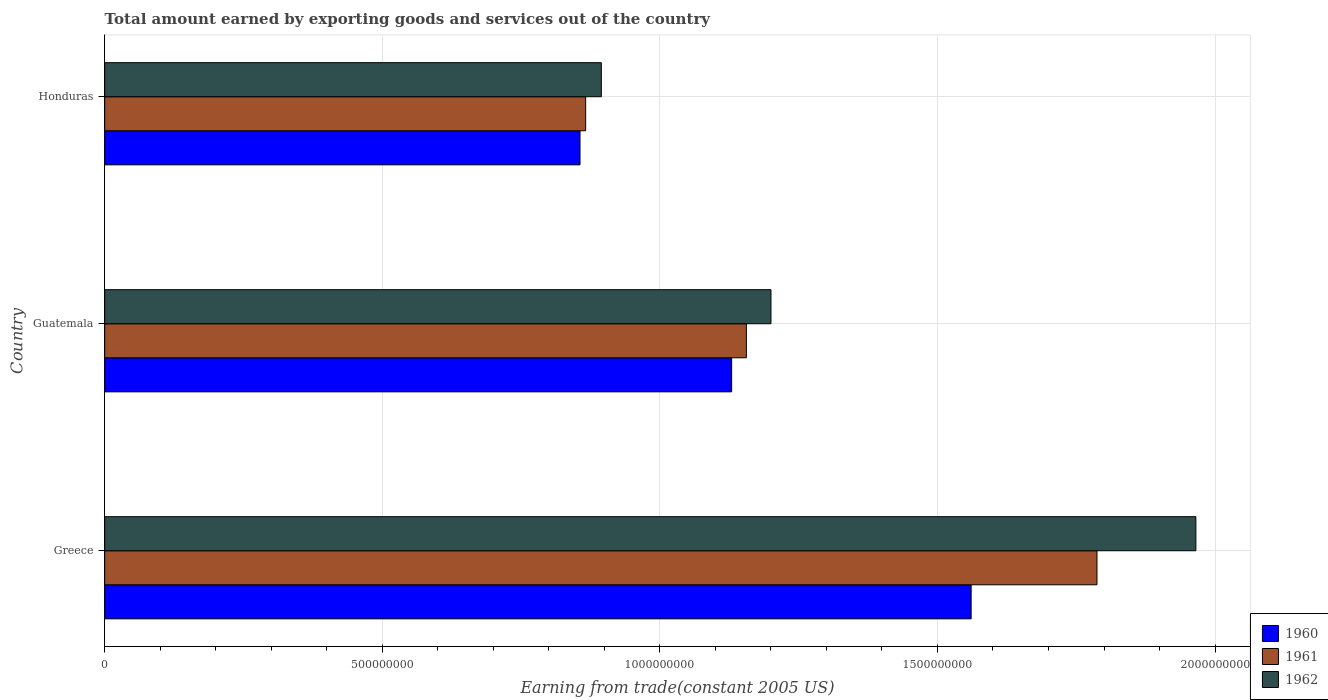How many different coloured bars are there?
Your answer should be very brief. 3. Are the number of bars on each tick of the Y-axis equal?
Your answer should be very brief. Yes. How many bars are there on the 1st tick from the top?
Make the answer very short. 3. How many bars are there on the 2nd tick from the bottom?
Ensure brevity in your answer.  3. What is the label of the 2nd group of bars from the top?
Give a very brief answer. Guatemala. What is the total amount earned by exporting goods and services in 1961 in Greece?
Provide a short and direct response. 1.79e+09. Across all countries, what is the maximum total amount earned by exporting goods and services in 1962?
Give a very brief answer. 1.97e+09. Across all countries, what is the minimum total amount earned by exporting goods and services in 1961?
Your response must be concise. 8.66e+08. In which country was the total amount earned by exporting goods and services in 1962 maximum?
Keep it short and to the point. Greece. In which country was the total amount earned by exporting goods and services in 1960 minimum?
Provide a short and direct response. Honduras. What is the total total amount earned by exporting goods and services in 1961 in the graph?
Offer a very short reply. 3.81e+09. What is the difference between the total amount earned by exporting goods and services in 1961 in Greece and that in Guatemala?
Give a very brief answer. 6.32e+08. What is the difference between the total amount earned by exporting goods and services in 1961 in Guatemala and the total amount earned by exporting goods and services in 1962 in Honduras?
Offer a very short reply. 2.61e+08. What is the average total amount earned by exporting goods and services in 1962 per country?
Your answer should be compact. 1.35e+09. What is the difference between the total amount earned by exporting goods and services in 1960 and total amount earned by exporting goods and services in 1961 in Honduras?
Provide a succinct answer. -1.02e+07. In how many countries, is the total amount earned by exporting goods and services in 1960 greater than 800000000 US$?
Offer a terse response. 3. What is the ratio of the total amount earned by exporting goods and services in 1960 in Greece to that in Guatemala?
Provide a short and direct response. 1.38. What is the difference between the highest and the second highest total amount earned by exporting goods and services in 1962?
Your answer should be compact. 7.65e+08. What is the difference between the highest and the lowest total amount earned by exporting goods and services in 1960?
Your response must be concise. 7.05e+08. In how many countries, is the total amount earned by exporting goods and services in 1961 greater than the average total amount earned by exporting goods and services in 1961 taken over all countries?
Make the answer very short. 1. What does the 1st bar from the top in Greece represents?
Provide a short and direct response. 1962. Is it the case that in every country, the sum of the total amount earned by exporting goods and services in 1962 and total amount earned by exporting goods and services in 1961 is greater than the total amount earned by exporting goods and services in 1960?
Give a very brief answer. Yes. How many bars are there?
Offer a very short reply. 9. Are all the bars in the graph horizontal?
Your answer should be compact. Yes. Are the values on the major ticks of X-axis written in scientific E-notation?
Keep it short and to the point. No. Does the graph contain any zero values?
Your response must be concise. No. Where does the legend appear in the graph?
Your response must be concise. Bottom right. How many legend labels are there?
Provide a short and direct response. 3. How are the legend labels stacked?
Provide a short and direct response. Vertical. What is the title of the graph?
Your answer should be compact. Total amount earned by exporting goods and services out of the country. What is the label or title of the X-axis?
Your response must be concise. Earning from trade(constant 2005 US). What is the Earning from trade(constant 2005 US) of 1960 in Greece?
Offer a very short reply. 1.56e+09. What is the Earning from trade(constant 2005 US) of 1961 in Greece?
Ensure brevity in your answer.  1.79e+09. What is the Earning from trade(constant 2005 US) in 1962 in Greece?
Keep it short and to the point. 1.97e+09. What is the Earning from trade(constant 2005 US) of 1960 in Guatemala?
Offer a terse response. 1.13e+09. What is the Earning from trade(constant 2005 US) of 1961 in Guatemala?
Your answer should be compact. 1.16e+09. What is the Earning from trade(constant 2005 US) in 1962 in Guatemala?
Offer a very short reply. 1.20e+09. What is the Earning from trade(constant 2005 US) of 1960 in Honduras?
Keep it short and to the point. 8.56e+08. What is the Earning from trade(constant 2005 US) in 1961 in Honduras?
Give a very brief answer. 8.66e+08. What is the Earning from trade(constant 2005 US) in 1962 in Honduras?
Keep it short and to the point. 8.95e+08. Across all countries, what is the maximum Earning from trade(constant 2005 US) of 1960?
Provide a succinct answer. 1.56e+09. Across all countries, what is the maximum Earning from trade(constant 2005 US) of 1961?
Ensure brevity in your answer.  1.79e+09. Across all countries, what is the maximum Earning from trade(constant 2005 US) in 1962?
Provide a succinct answer. 1.97e+09. Across all countries, what is the minimum Earning from trade(constant 2005 US) in 1960?
Offer a terse response. 8.56e+08. Across all countries, what is the minimum Earning from trade(constant 2005 US) in 1961?
Give a very brief answer. 8.66e+08. Across all countries, what is the minimum Earning from trade(constant 2005 US) of 1962?
Your answer should be very brief. 8.95e+08. What is the total Earning from trade(constant 2005 US) of 1960 in the graph?
Ensure brevity in your answer.  3.55e+09. What is the total Earning from trade(constant 2005 US) in 1961 in the graph?
Make the answer very short. 3.81e+09. What is the total Earning from trade(constant 2005 US) of 1962 in the graph?
Provide a short and direct response. 4.06e+09. What is the difference between the Earning from trade(constant 2005 US) in 1960 in Greece and that in Guatemala?
Provide a short and direct response. 4.31e+08. What is the difference between the Earning from trade(constant 2005 US) in 1961 in Greece and that in Guatemala?
Ensure brevity in your answer.  6.32e+08. What is the difference between the Earning from trade(constant 2005 US) of 1962 in Greece and that in Guatemala?
Your answer should be compact. 7.65e+08. What is the difference between the Earning from trade(constant 2005 US) of 1960 in Greece and that in Honduras?
Your answer should be very brief. 7.05e+08. What is the difference between the Earning from trade(constant 2005 US) in 1961 in Greece and that in Honduras?
Your response must be concise. 9.21e+08. What is the difference between the Earning from trade(constant 2005 US) in 1962 in Greece and that in Honduras?
Ensure brevity in your answer.  1.07e+09. What is the difference between the Earning from trade(constant 2005 US) of 1960 in Guatemala and that in Honduras?
Your answer should be compact. 2.73e+08. What is the difference between the Earning from trade(constant 2005 US) in 1961 in Guatemala and that in Honduras?
Make the answer very short. 2.89e+08. What is the difference between the Earning from trade(constant 2005 US) in 1962 in Guatemala and that in Honduras?
Provide a succinct answer. 3.06e+08. What is the difference between the Earning from trade(constant 2005 US) of 1960 in Greece and the Earning from trade(constant 2005 US) of 1961 in Guatemala?
Provide a succinct answer. 4.05e+08. What is the difference between the Earning from trade(constant 2005 US) of 1960 in Greece and the Earning from trade(constant 2005 US) of 1962 in Guatemala?
Offer a very short reply. 3.61e+08. What is the difference between the Earning from trade(constant 2005 US) in 1961 in Greece and the Earning from trade(constant 2005 US) in 1962 in Guatemala?
Your answer should be compact. 5.87e+08. What is the difference between the Earning from trade(constant 2005 US) in 1960 in Greece and the Earning from trade(constant 2005 US) in 1961 in Honduras?
Offer a terse response. 6.94e+08. What is the difference between the Earning from trade(constant 2005 US) in 1960 in Greece and the Earning from trade(constant 2005 US) in 1962 in Honduras?
Provide a succinct answer. 6.66e+08. What is the difference between the Earning from trade(constant 2005 US) in 1961 in Greece and the Earning from trade(constant 2005 US) in 1962 in Honduras?
Your answer should be very brief. 8.93e+08. What is the difference between the Earning from trade(constant 2005 US) of 1960 in Guatemala and the Earning from trade(constant 2005 US) of 1961 in Honduras?
Offer a terse response. 2.63e+08. What is the difference between the Earning from trade(constant 2005 US) in 1960 in Guatemala and the Earning from trade(constant 2005 US) in 1962 in Honduras?
Give a very brief answer. 2.35e+08. What is the difference between the Earning from trade(constant 2005 US) of 1961 in Guatemala and the Earning from trade(constant 2005 US) of 1962 in Honduras?
Provide a short and direct response. 2.61e+08. What is the average Earning from trade(constant 2005 US) of 1960 per country?
Your answer should be very brief. 1.18e+09. What is the average Earning from trade(constant 2005 US) of 1961 per country?
Keep it short and to the point. 1.27e+09. What is the average Earning from trade(constant 2005 US) in 1962 per country?
Your answer should be compact. 1.35e+09. What is the difference between the Earning from trade(constant 2005 US) of 1960 and Earning from trade(constant 2005 US) of 1961 in Greece?
Your answer should be very brief. -2.27e+08. What is the difference between the Earning from trade(constant 2005 US) of 1960 and Earning from trade(constant 2005 US) of 1962 in Greece?
Your response must be concise. -4.05e+08. What is the difference between the Earning from trade(constant 2005 US) of 1961 and Earning from trade(constant 2005 US) of 1962 in Greece?
Provide a short and direct response. -1.78e+08. What is the difference between the Earning from trade(constant 2005 US) in 1960 and Earning from trade(constant 2005 US) in 1961 in Guatemala?
Ensure brevity in your answer.  -2.66e+07. What is the difference between the Earning from trade(constant 2005 US) in 1960 and Earning from trade(constant 2005 US) in 1962 in Guatemala?
Your answer should be very brief. -7.09e+07. What is the difference between the Earning from trade(constant 2005 US) in 1961 and Earning from trade(constant 2005 US) in 1962 in Guatemala?
Ensure brevity in your answer.  -4.43e+07. What is the difference between the Earning from trade(constant 2005 US) in 1960 and Earning from trade(constant 2005 US) in 1961 in Honduras?
Your answer should be compact. -1.02e+07. What is the difference between the Earning from trade(constant 2005 US) in 1960 and Earning from trade(constant 2005 US) in 1962 in Honduras?
Keep it short and to the point. -3.84e+07. What is the difference between the Earning from trade(constant 2005 US) in 1961 and Earning from trade(constant 2005 US) in 1962 in Honduras?
Provide a succinct answer. -2.82e+07. What is the ratio of the Earning from trade(constant 2005 US) in 1960 in Greece to that in Guatemala?
Offer a very short reply. 1.38. What is the ratio of the Earning from trade(constant 2005 US) of 1961 in Greece to that in Guatemala?
Offer a very short reply. 1.55. What is the ratio of the Earning from trade(constant 2005 US) in 1962 in Greece to that in Guatemala?
Offer a terse response. 1.64. What is the ratio of the Earning from trade(constant 2005 US) in 1960 in Greece to that in Honduras?
Give a very brief answer. 1.82. What is the ratio of the Earning from trade(constant 2005 US) in 1961 in Greece to that in Honduras?
Provide a short and direct response. 2.06. What is the ratio of the Earning from trade(constant 2005 US) of 1962 in Greece to that in Honduras?
Offer a terse response. 2.2. What is the ratio of the Earning from trade(constant 2005 US) in 1960 in Guatemala to that in Honduras?
Provide a short and direct response. 1.32. What is the ratio of the Earning from trade(constant 2005 US) of 1961 in Guatemala to that in Honduras?
Offer a terse response. 1.33. What is the ratio of the Earning from trade(constant 2005 US) of 1962 in Guatemala to that in Honduras?
Offer a terse response. 1.34. What is the difference between the highest and the second highest Earning from trade(constant 2005 US) of 1960?
Your answer should be very brief. 4.31e+08. What is the difference between the highest and the second highest Earning from trade(constant 2005 US) of 1961?
Provide a succinct answer. 6.32e+08. What is the difference between the highest and the second highest Earning from trade(constant 2005 US) of 1962?
Provide a succinct answer. 7.65e+08. What is the difference between the highest and the lowest Earning from trade(constant 2005 US) of 1960?
Your answer should be compact. 7.05e+08. What is the difference between the highest and the lowest Earning from trade(constant 2005 US) of 1961?
Offer a terse response. 9.21e+08. What is the difference between the highest and the lowest Earning from trade(constant 2005 US) in 1962?
Your answer should be very brief. 1.07e+09. 